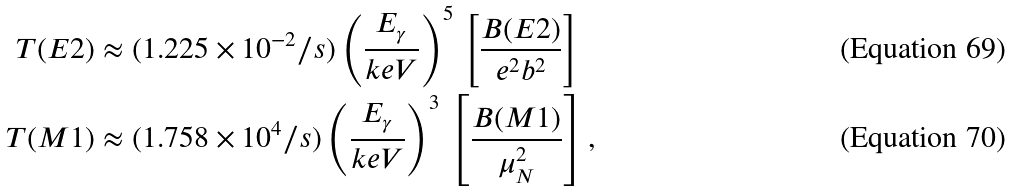<formula> <loc_0><loc_0><loc_500><loc_500>T ( E 2 ) & \approx ( 1 . 2 2 5 \times 1 0 ^ { - 2 } / s ) \left ( \frac { E _ { \gamma } } { k e V } \right ) ^ { 5 } \, \left [ \frac { B ( E 2 ) } { e ^ { 2 } b ^ { 2 } } \right ] \\ T ( M 1 ) & \approx ( 1 . 7 5 8 \times 1 0 ^ { 4 } / s ) \left ( \frac { E _ { \gamma } } { k e V } \right ) ^ { 3 } \, \left [ \frac { B ( M 1 ) } { \mu _ { N } ^ { 2 } } \right ] ,</formula> 